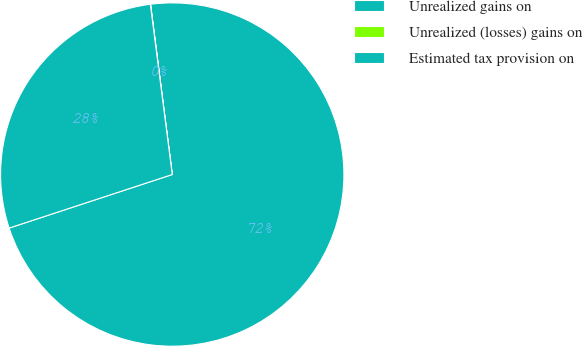Convert chart. <chart><loc_0><loc_0><loc_500><loc_500><pie_chart><fcel>Unrealized gains on<fcel>Unrealized (losses) gains on<fcel>Estimated tax provision on<nl><fcel>71.97%<fcel>0.02%<fcel>28.01%<nl></chart> 